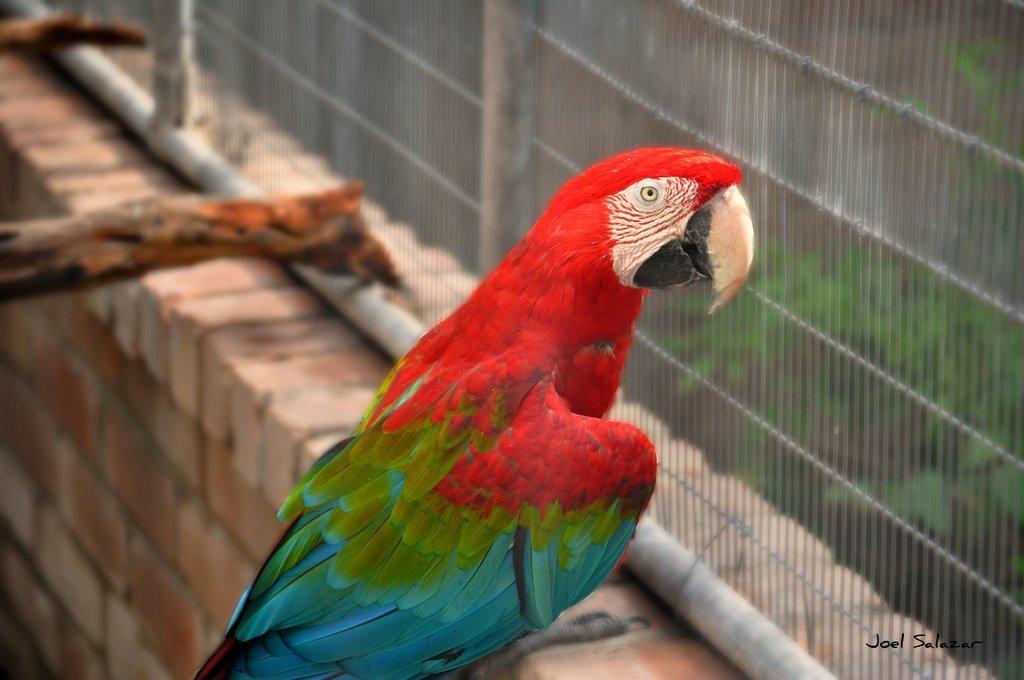Describe this image in one or two sentences. In this image there is a parrot sitting on the wall. Beside her there are two wooden sticks. In front of the bird there is a closed mesh fencing. At the background there are trees. 